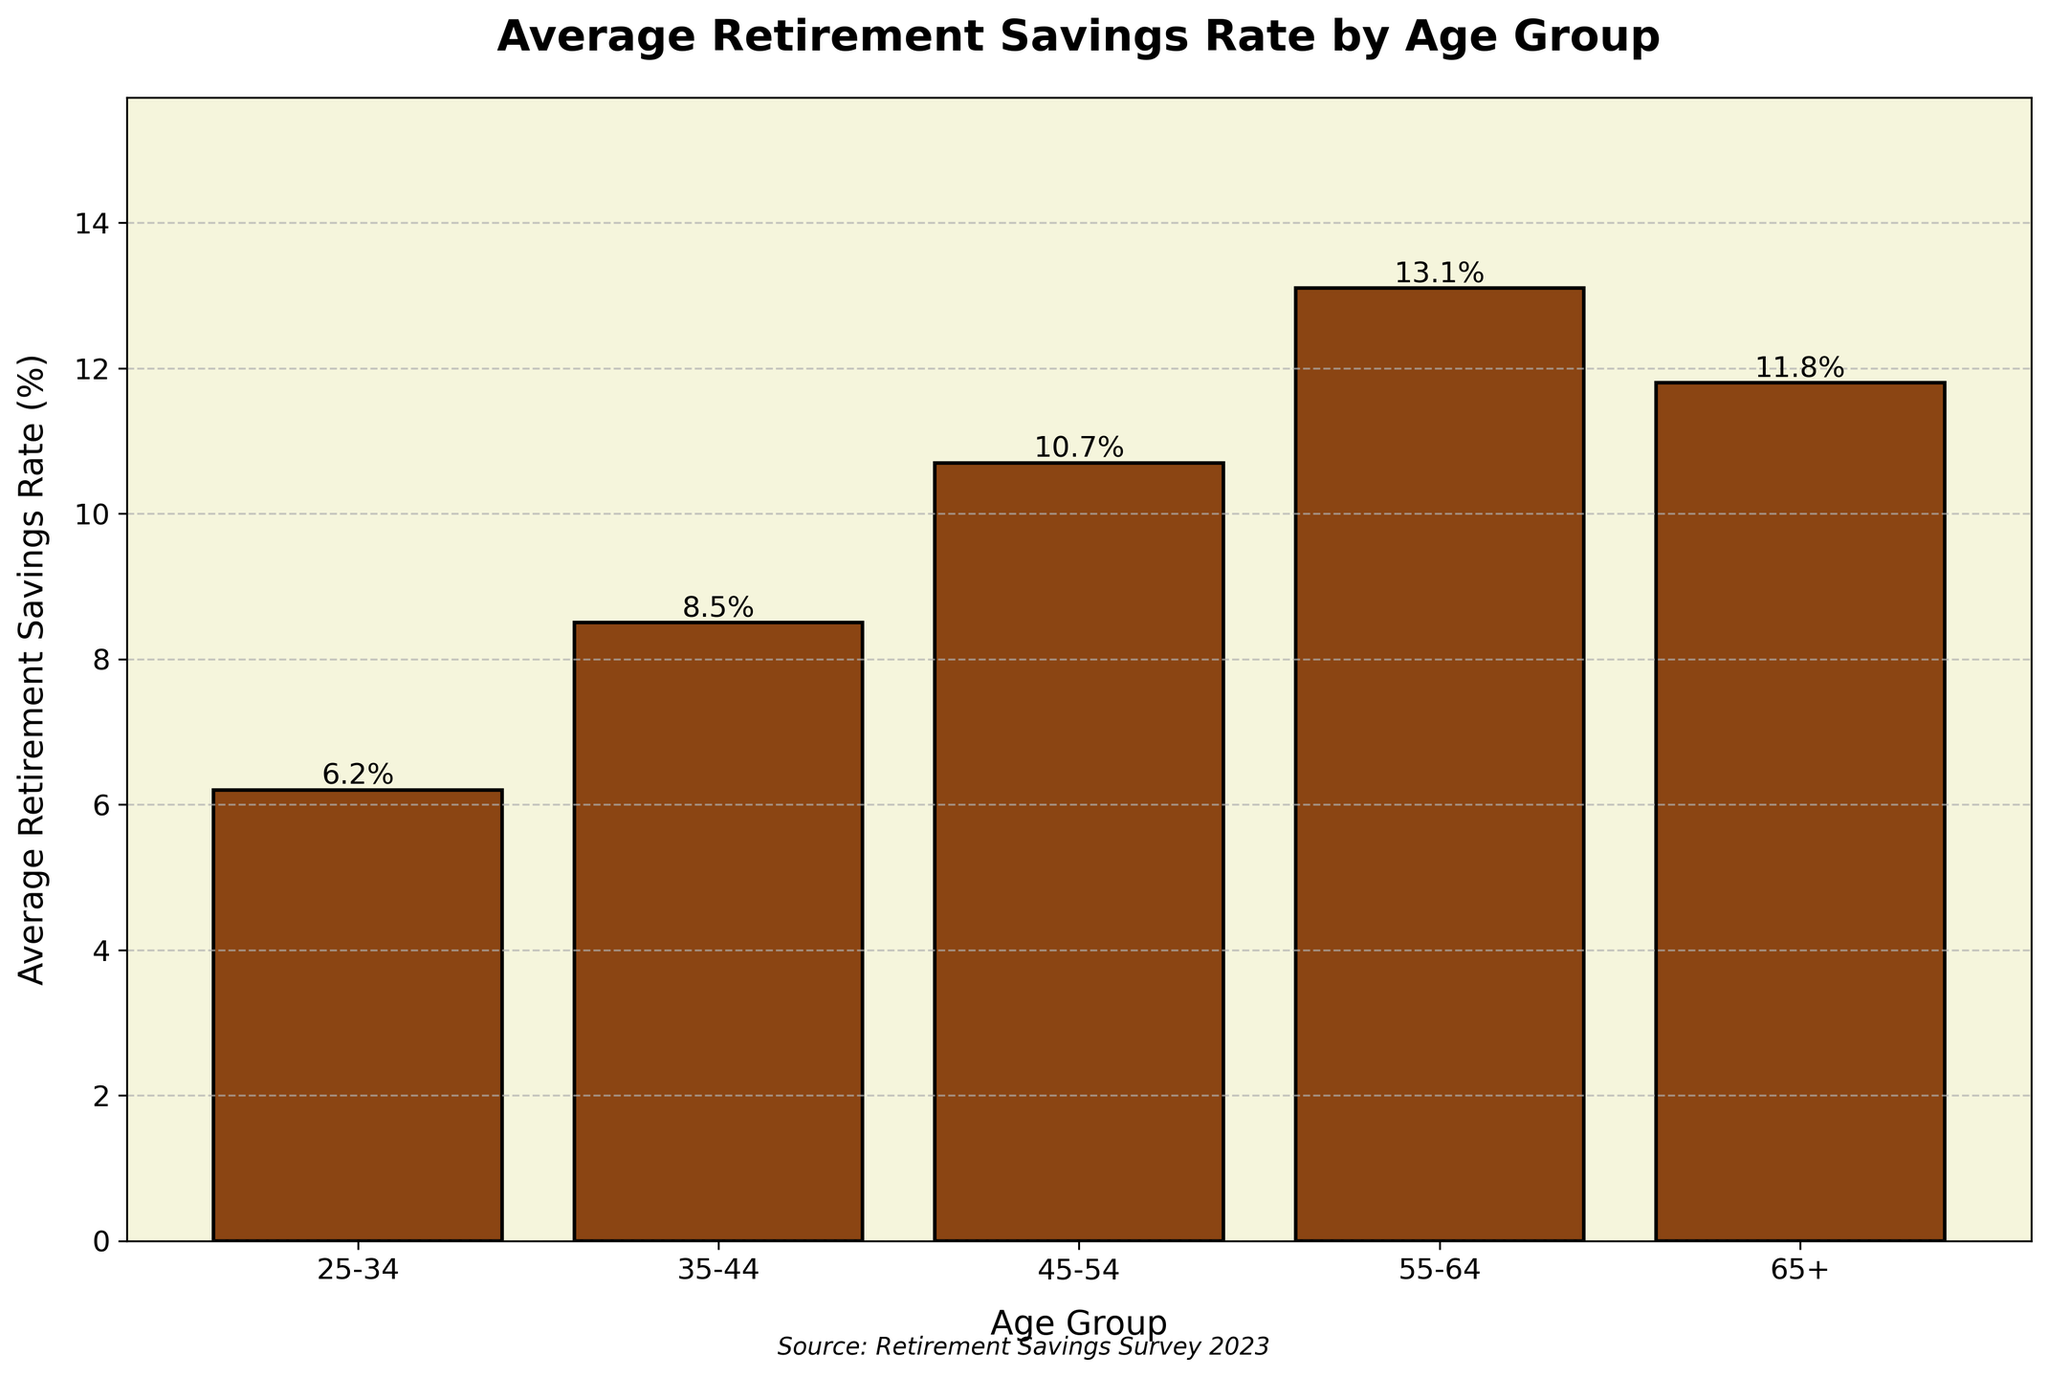What's the average retirement savings rate for the 55-64 age group? The bar for the 55-64 age group reaches its highest point at 13.1%. This value is shown on top of the bar.
Answer: 13.1% Which age group has the lowest average retirement savings rate? By inspecting the height of the bars, we see that the bar for the 25-34 age group is the shortest, indicating the lowest savings rate. The value is 6.2%.
Answer: 25-34 How much higher is the retirement savings rate of the 45-54 age group compared to the 25-34 age group? The savings rate for the 45-54 age group is 10.7%, and for the 25-34 age group, it is 6.2%. The difference is 10.7% - 6.2% = 4.5%.
Answer: 4.5% What is the savings rate difference between the 55-64 age group and the 65+ age group? The savings rate for the 55-64 age group is 13.1%, and for the 65+ age group, it is 11.8%. The difference is 13.1% - 11.8% = 1.3%.
Answer: 1.3% Which age group has a higher average retirement savings rate: 35-44 or 45-54? By comparing the heights of the bars, we see that the 45-54 age group (10.7%) has a higher savings rate than the 35-44 age group (8.5%).
Answer: 45-54 What is the combined average retirement savings rate of the 35-44 and 45-54 age groups? The savings rates are 8.5% for the 35-44 age group and 10.7% for the 45-54 age group. Their combined rate is 8.5% + 10.7% = 19.2%.
Answer: 19.2% Compare the heights of the bars representing the 45-54 and 55-64 age groups. How much taller is the bar for the 55-64 age group? The bar for the 45-54 age group is at 10.7%, and for the 55-64 age group, it is at 13.1%. The height difference is 13.1% - 10.7% = 2.4%.
Answer: 2.4% Is the average retirement savings rate of the 65+ age group greater or less than that of the 45-54 age group? The savings rate for the 65+ age group is 11.8%, and for the 45-54 age group, it is 10.7%. Thus, the 65+ age group's rate is greater.
Answer: Greater Considering only the visual attributes, which age group's bar is nearly equal in height to the 45-54 age group? Visually comparing the bars, the 35-44 age group's bar appears similar but slightly shorter. Its value is 8.5% compared to 10.7% for the 45-54 age group.
Answer: 35-44 